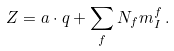Convert formula to latex. <formula><loc_0><loc_0><loc_500><loc_500>Z = { a } \cdot { q } + \sum _ { f } N _ { f } m _ { I } ^ { f } \, .</formula> 